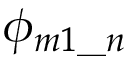Convert formula to latex. <formula><loc_0><loc_0><loc_500><loc_500>\phi _ { m 1 \_ n }</formula> 